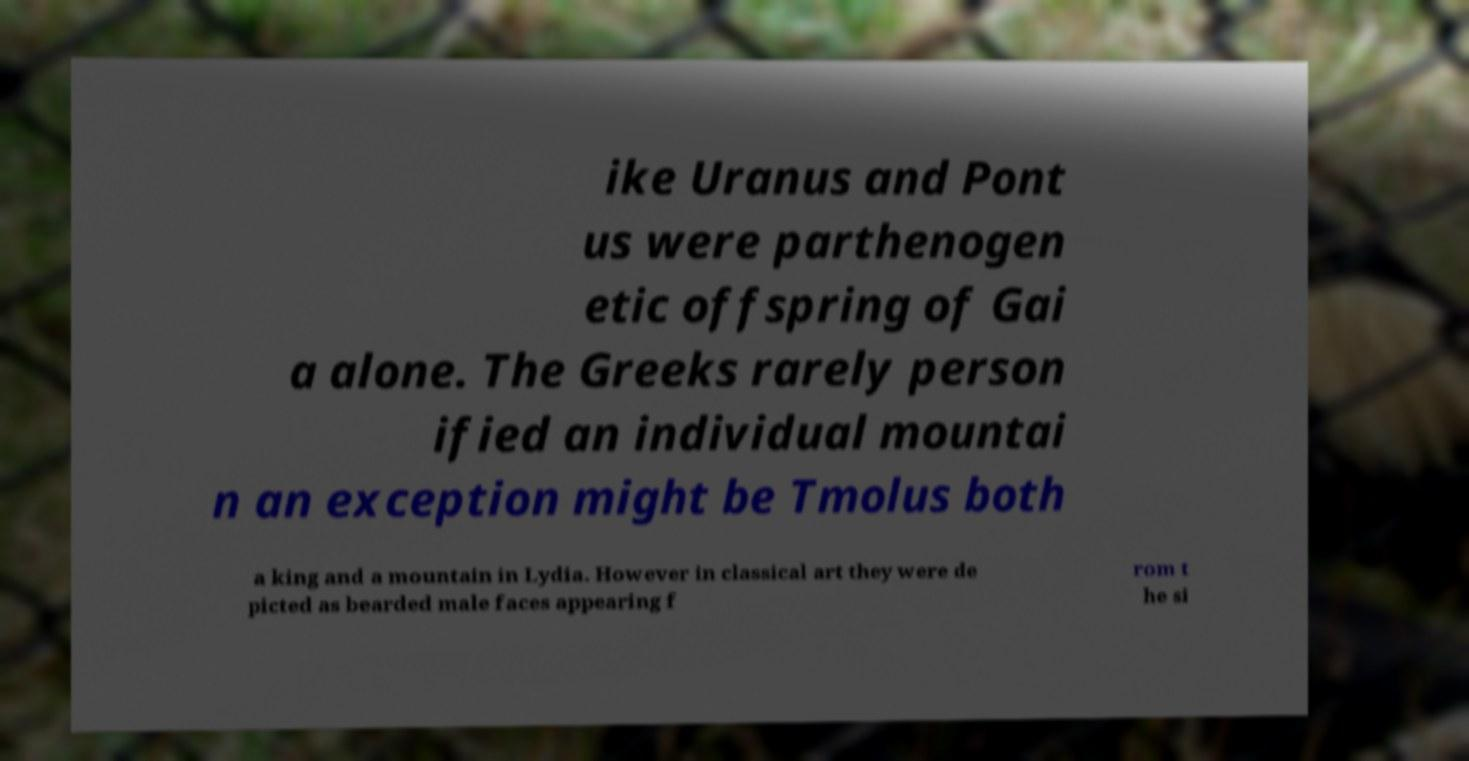What messages or text are displayed in this image? I need them in a readable, typed format. ike Uranus and Pont us were parthenogen etic offspring of Gai a alone. The Greeks rarely person ified an individual mountai n an exception might be Tmolus both a king and a mountain in Lydia. However in classical art they were de picted as bearded male faces appearing f rom t he si 